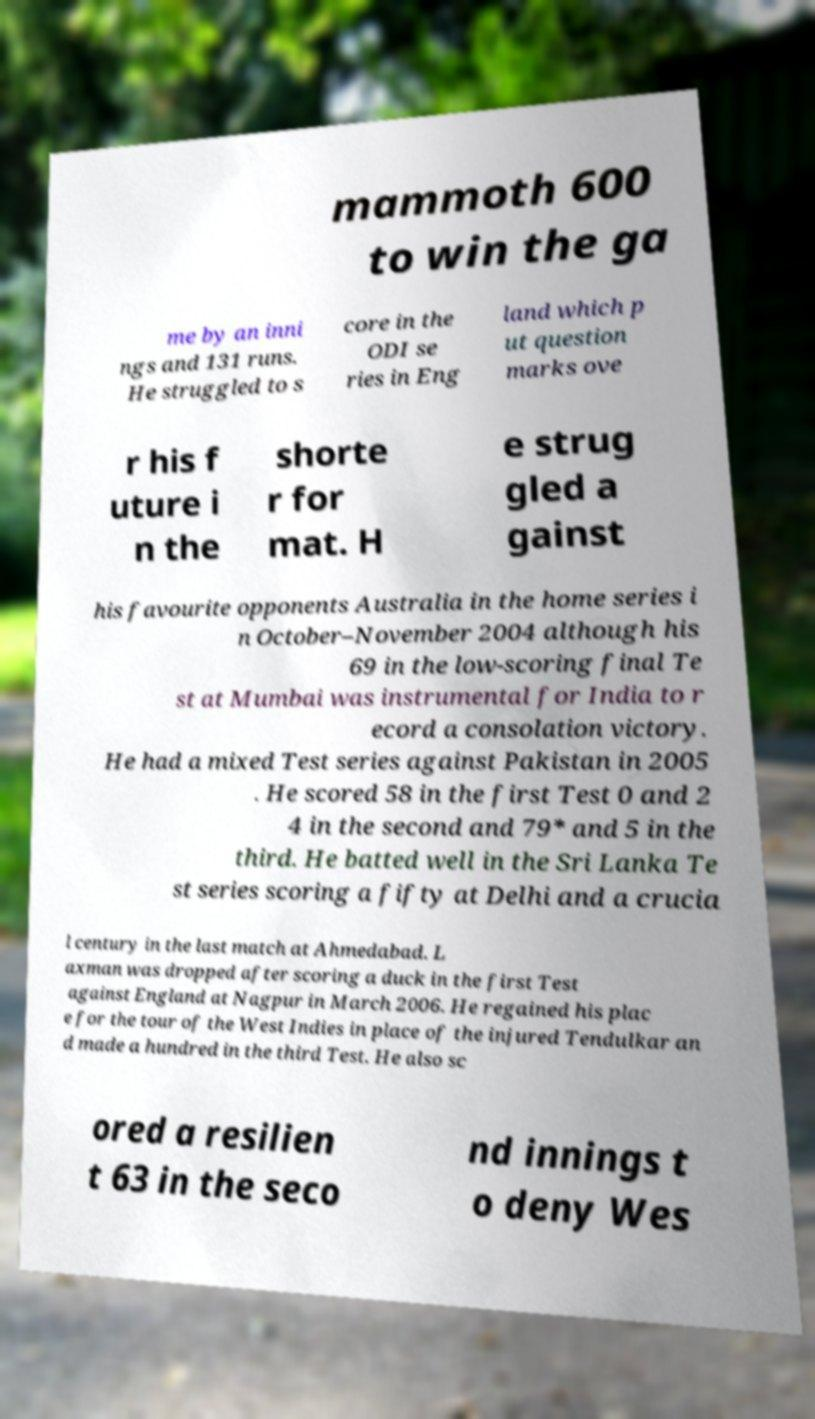For documentation purposes, I need the text within this image transcribed. Could you provide that? mammoth 600 to win the ga me by an inni ngs and 131 runs. He struggled to s core in the ODI se ries in Eng land which p ut question marks ove r his f uture i n the shorte r for mat. H e strug gled a gainst his favourite opponents Australia in the home series i n October–November 2004 although his 69 in the low-scoring final Te st at Mumbai was instrumental for India to r ecord a consolation victory. He had a mixed Test series against Pakistan in 2005 . He scored 58 in the first Test 0 and 2 4 in the second and 79* and 5 in the third. He batted well in the Sri Lanka Te st series scoring a fifty at Delhi and a crucia l century in the last match at Ahmedabad. L axman was dropped after scoring a duck in the first Test against England at Nagpur in March 2006. He regained his plac e for the tour of the West Indies in place of the injured Tendulkar an d made a hundred in the third Test. He also sc ored a resilien t 63 in the seco nd innings t o deny Wes 